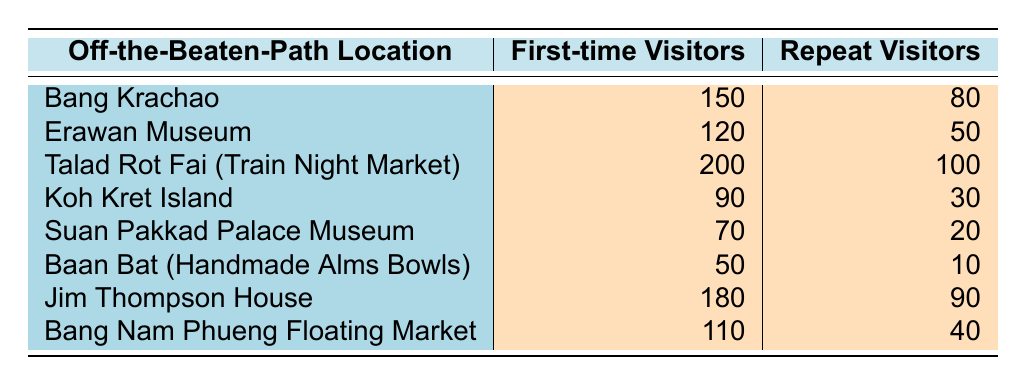What is the highest frequency of visits by first-time visitors to an off-the-beaten-path location? The highest number of visits by first-time visitors is recorded at Talad Rot Fai (Train Night Market) with 200 visitors.
Answer: 200 How many repeat visitors did Jim Thompson House receive? According to the table, Jim Thompson House had 90 repeat visitors.
Answer: 90 Which location had the lowest number of first-time visitors and how many were there? The location with the lowest number of first-time visitors is Baan Bat (Handmade Alms Bowls), which had 50 visitors.
Answer: 50 Is it true that Koh Kret Island had more repeat visitors than Suan Pakkad Palace Museum? Yes, Koh Kret Island had 30 repeat visitors, while Suan Pakkad Palace Museum had only 20 repeat visitors, confirming that Koh Kret had more.
Answer: Yes What is the difference in the number of first-time visitors between Bang Krachao and Erawan Museum? Bang Krachao had 150 first-time visitors and Erawan Museum had 120, so the difference is 150 - 120 = 30.
Answer: 30 Which location attracted the most combined visitors (first-time + repeat)? To find the combined visitors for each location: Talad Rot Fai (300), Jim Thompson House (270), and Bang Krachao (230), among others. The maximum is 300 from Talad Rot Fai (Train Night Market).
Answer: Talad Rot Fai (Train Night Market) What is the average number of first-time visitors across all locations? First, sum the first-time visitors: 150 + 120 + 200 + 90 + 70 + 50 + 180 + 110 = 1020. There are 8 locations, so average = 1020 / 8 = 127.5.
Answer: 127.5 How many locations had more than 100 first-time visitors? By reviewing the table, the locations with more than 100 first-time visitors are: Talad Rot Fai (200), Bang Krachao (150), and Jim Thompson House (180). That makes a total of 3 locations.
Answer: 3 Which location had a greater percentage of first-time visitors compared to repeat visitors? To determine this, calculate the percentage for each: Bang Krachao (150/230) = ~65.2%, Erawan Museum (120/170) = ~70.6%, Talad Rot Fai (200/300) = ~66.7%, etc. The highest percentage is for Erawan Museum at 70.6%.
Answer: Erawan Museum 